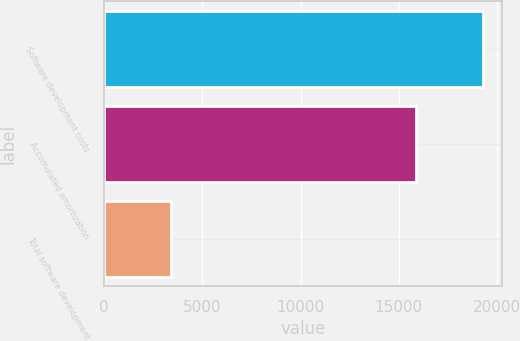Convert chart. <chart><loc_0><loc_0><loc_500><loc_500><bar_chart><fcel>Software development costs<fcel>Accumulated amortization<fcel>Total software development<nl><fcel>19302<fcel>15882<fcel>3420<nl></chart> 